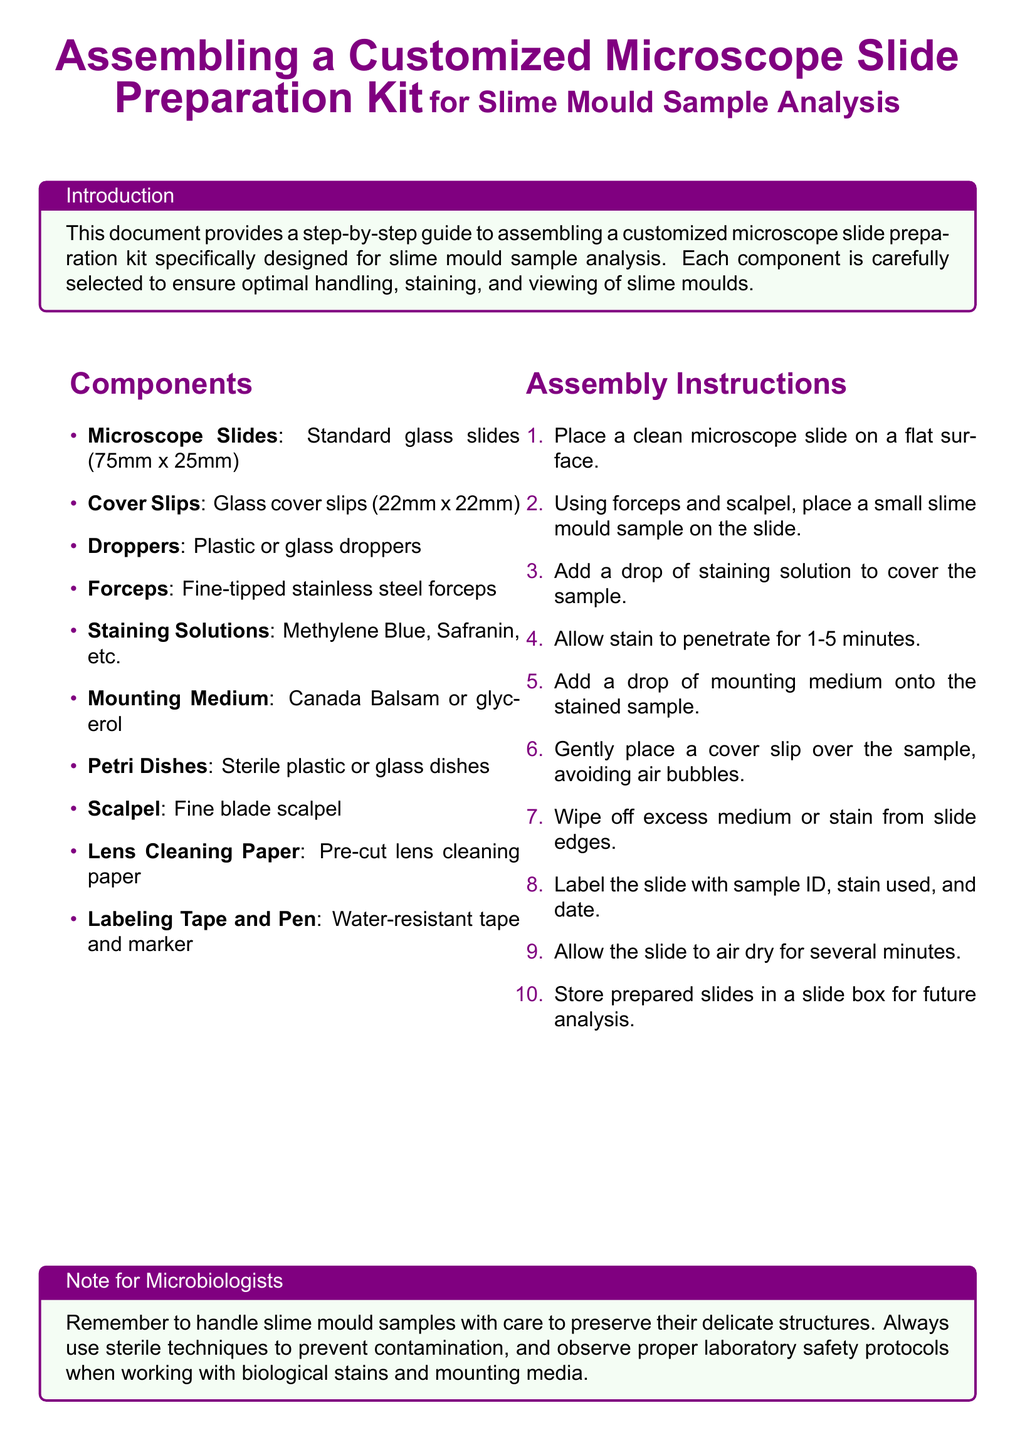What are the dimensions of the microscope slides? The dimensions of the microscope slides are specified in the components section as 75mm x 25mm.
Answer: 75mm x 25mm How many staining solutions are mentioned? The document lists various staining solutions in the components section but does not specify the exact number. It names at least two, which are Methylene Blue and Safranin.
Answer: 2 What is the purpose of the cover slip? The instructions indicate that the cover slip is to be placed over the stained sample to avoid air bubbles.
Answer: Avoiding air bubbles What should you do before labeling the slide? The assembly instructions specify to air dry the slide for several minutes before labeling it.
Answer: Air dry What is the last step in the assembly instructions? The final step in the assembly instructions is to store prepared slides in a slide box for future analysis.
Answer: Store in a slide box 